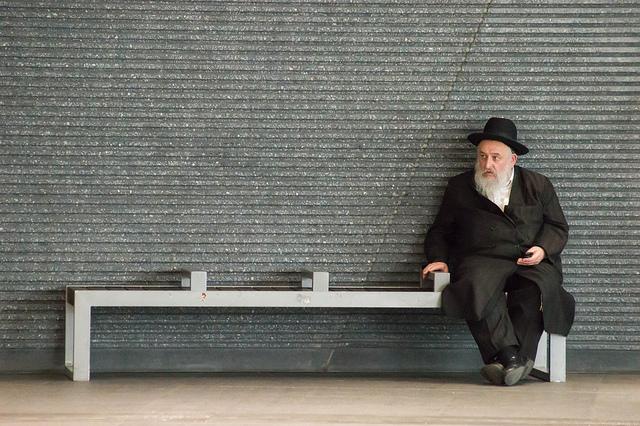Is the man looking at a cell phone?
Quick response, please. No. What is he sitting on?
Short answer required. Bench. What color is the man's beard?
Be succinct. White. Is this man orthodox?
Keep it brief. Yes. 